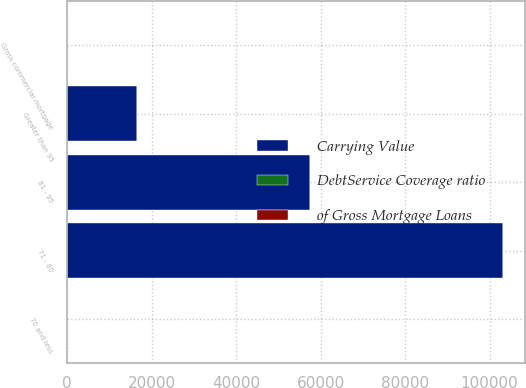Convert chart. <chart><loc_0><loc_0><loc_500><loc_500><stacked_bar_chart><ecel><fcel>70 and less<fcel>71 - 80<fcel>81 - 95<fcel>Greater than 95<fcel>Gross commercial mortgage<nl><fcel>Carrying Value<fcel>4.3<fcel>103152<fcel>57413<fcel>16550<fcel>4.3<nl><fcel>DebtService Coverage ratio<fcel>86.6<fcel>7.8<fcel>4.3<fcel>1.3<fcel>100<nl><fcel>of Gross Mortgage Loans<fcel>1.95<fcel>1.3<fcel>1.04<fcel>1.02<fcel>1.85<nl></chart> 